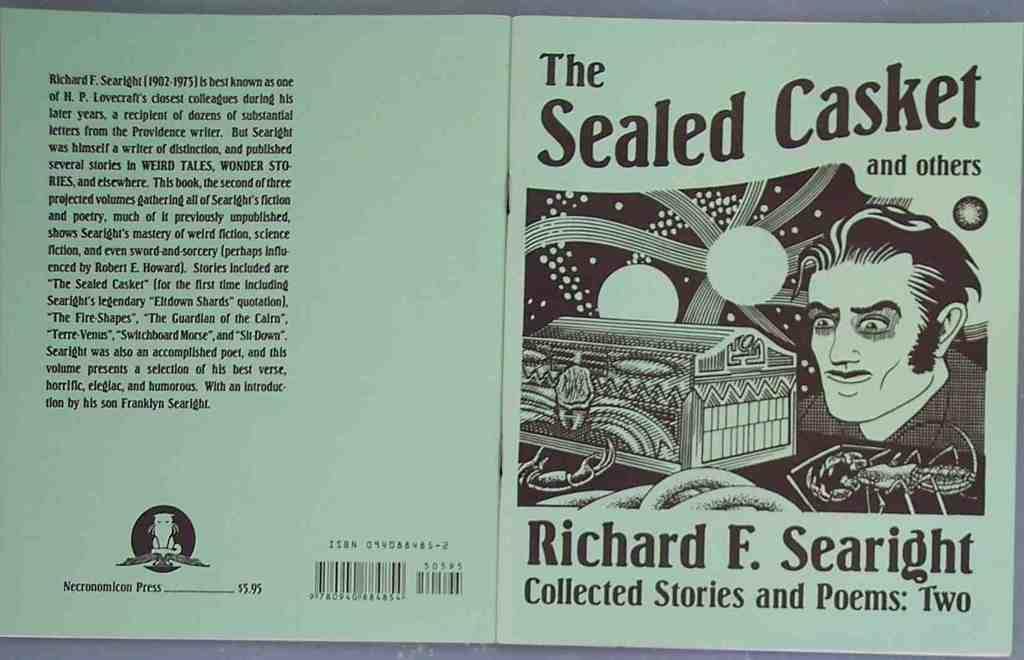Provide a one-sentence caption for the provided image. A collection of stories by Richard F. Searight. 